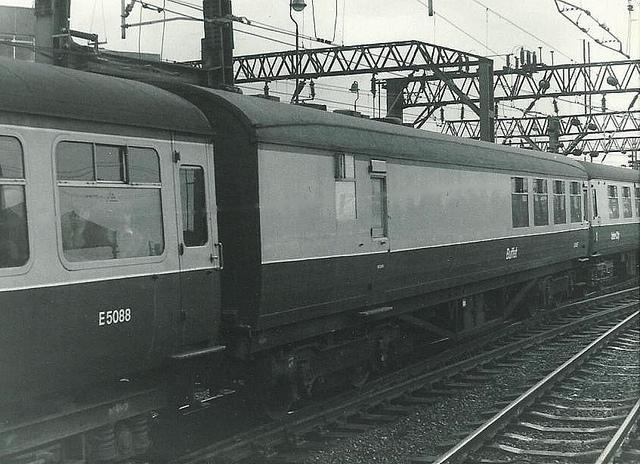What quality photo is this?
Write a very short answer. Black and white. How many windows are there?
Short answer required. 12. Are there people inside the train?
Be succinct. Yes. 